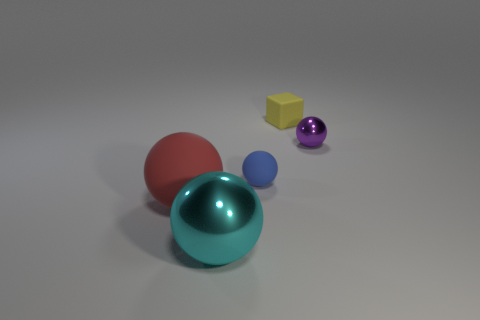Add 3 blocks. How many objects exist? 8 Subtract all cyan balls. How many balls are left? 3 Subtract all tiny purple balls. How many balls are left? 3 Subtract 1 spheres. How many spheres are left? 3 Subtract all green balls. How many cyan cubes are left? 0 Subtract all small red metal cubes. Subtract all matte things. How many objects are left? 2 Add 1 big red balls. How many big red balls are left? 2 Add 2 large blue metallic objects. How many large blue metallic objects exist? 2 Subtract 0 cyan cylinders. How many objects are left? 5 Subtract all blocks. How many objects are left? 4 